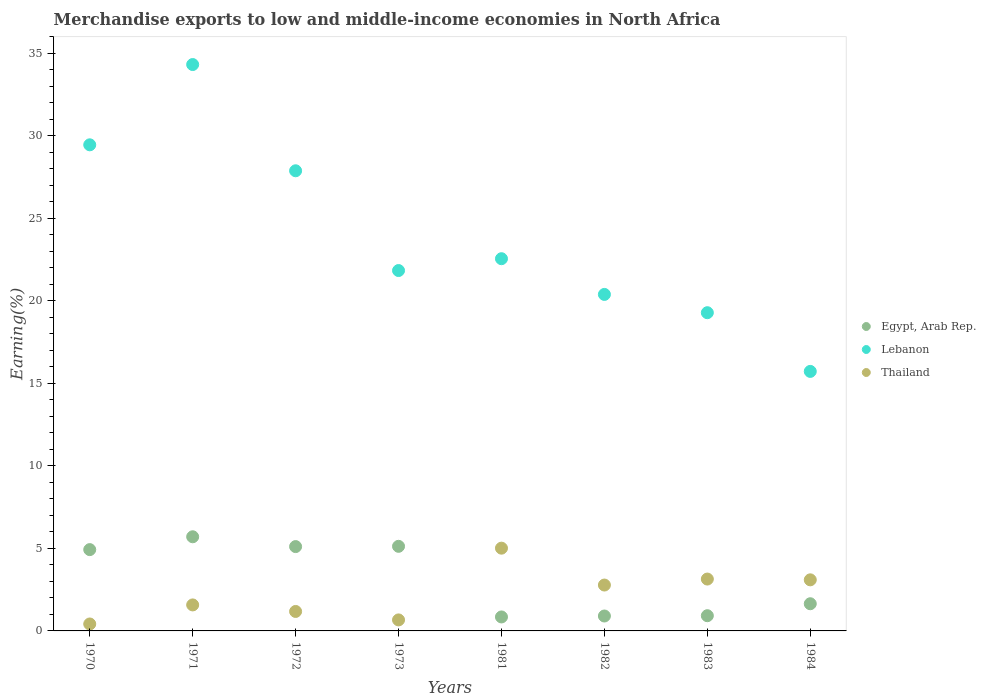Is the number of dotlines equal to the number of legend labels?
Offer a terse response. Yes. What is the percentage of amount earned from merchandise exports in Thailand in 1982?
Your response must be concise. 2.78. Across all years, what is the maximum percentage of amount earned from merchandise exports in Thailand?
Provide a succinct answer. 5.02. Across all years, what is the minimum percentage of amount earned from merchandise exports in Egypt, Arab Rep.?
Provide a succinct answer. 0.85. What is the total percentage of amount earned from merchandise exports in Egypt, Arab Rep. in the graph?
Your answer should be compact. 25.19. What is the difference between the percentage of amount earned from merchandise exports in Lebanon in 1972 and that in 1984?
Your response must be concise. 12.16. What is the difference between the percentage of amount earned from merchandise exports in Egypt, Arab Rep. in 1981 and the percentage of amount earned from merchandise exports in Lebanon in 1970?
Ensure brevity in your answer.  -28.62. What is the average percentage of amount earned from merchandise exports in Lebanon per year?
Ensure brevity in your answer.  23.94. In the year 1984, what is the difference between the percentage of amount earned from merchandise exports in Lebanon and percentage of amount earned from merchandise exports in Thailand?
Your answer should be very brief. 12.63. In how many years, is the percentage of amount earned from merchandise exports in Thailand greater than 23 %?
Your answer should be very brief. 0. What is the ratio of the percentage of amount earned from merchandise exports in Egypt, Arab Rep. in 1972 to that in 1973?
Make the answer very short. 1. What is the difference between the highest and the second highest percentage of amount earned from merchandise exports in Egypt, Arab Rep.?
Offer a terse response. 0.58. What is the difference between the highest and the lowest percentage of amount earned from merchandise exports in Lebanon?
Give a very brief answer. 18.6. In how many years, is the percentage of amount earned from merchandise exports in Thailand greater than the average percentage of amount earned from merchandise exports in Thailand taken over all years?
Offer a very short reply. 4. Is it the case that in every year, the sum of the percentage of amount earned from merchandise exports in Egypt, Arab Rep. and percentage of amount earned from merchandise exports in Thailand  is greater than the percentage of amount earned from merchandise exports in Lebanon?
Make the answer very short. No. Is the percentage of amount earned from merchandise exports in Egypt, Arab Rep. strictly greater than the percentage of amount earned from merchandise exports in Lebanon over the years?
Ensure brevity in your answer.  No. Is the percentage of amount earned from merchandise exports in Egypt, Arab Rep. strictly less than the percentage of amount earned from merchandise exports in Thailand over the years?
Your response must be concise. No. Are the values on the major ticks of Y-axis written in scientific E-notation?
Offer a very short reply. No. Does the graph contain any zero values?
Your response must be concise. No. Does the graph contain grids?
Offer a terse response. No. Where does the legend appear in the graph?
Keep it short and to the point. Center right. How are the legend labels stacked?
Make the answer very short. Vertical. What is the title of the graph?
Provide a succinct answer. Merchandise exports to low and middle-income economies in North Africa. Does "High income: nonOECD" appear as one of the legend labels in the graph?
Keep it short and to the point. No. What is the label or title of the X-axis?
Ensure brevity in your answer.  Years. What is the label or title of the Y-axis?
Make the answer very short. Earning(%). What is the Earning(%) in Egypt, Arab Rep. in 1970?
Offer a terse response. 4.93. What is the Earning(%) of Lebanon in 1970?
Keep it short and to the point. 29.46. What is the Earning(%) in Thailand in 1970?
Provide a short and direct response. 0.42. What is the Earning(%) in Egypt, Arab Rep. in 1971?
Your answer should be compact. 5.71. What is the Earning(%) of Lebanon in 1971?
Your response must be concise. 34.33. What is the Earning(%) in Thailand in 1971?
Ensure brevity in your answer.  1.58. What is the Earning(%) in Egypt, Arab Rep. in 1972?
Keep it short and to the point. 5.11. What is the Earning(%) in Lebanon in 1972?
Give a very brief answer. 27.89. What is the Earning(%) in Thailand in 1972?
Your answer should be very brief. 1.18. What is the Earning(%) of Egypt, Arab Rep. in 1973?
Your response must be concise. 5.13. What is the Earning(%) in Lebanon in 1973?
Ensure brevity in your answer.  21.84. What is the Earning(%) in Thailand in 1973?
Offer a terse response. 0.67. What is the Earning(%) of Egypt, Arab Rep. in 1981?
Ensure brevity in your answer.  0.85. What is the Earning(%) of Lebanon in 1981?
Ensure brevity in your answer.  22.56. What is the Earning(%) in Thailand in 1981?
Ensure brevity in your answer.  5.02. What is the Earning(%) of Egypt, Arab Rep. in 1982?
Your answer should be compact. 0.9. What is the Earning(%) of Lebanon in 1982?
Offer a very short reply. 20.4. What is the Earning(%) of Thailand in 1982?
Make the answer very short. 2.78. What is the Earning(%) of Egypt, Arab Rep. in 1983?
Give a very brief answer. 0.92. What is the Earning(%) of Lebanon in 1983?
Keep it short and to the point. 19.29. What is the Earning(%) in Thailand in 1983?
Your answer should be very brief. 3.14. What is the Earning(%) in Egypt, Arab Rep. in 1984?
Your answer should be very brief. 1.65. What is the Earning(%) in Lebanon in 1984?
Provide a succinct answer. 15.73. What is the Earning(%) in Thailand in 1984?
Offer a very short reply. 3.1. Across all years, what is the maximum Earning(%) of Egypt, Arab Rep.?
Offer a terse response. 5.71. Across all years, what is the maximum Earning(%) of Lebanon?
Your answer should be compact. 34.33. Across all years, what is the maximum Earning(%) of Thailand?
Your answer should be very brief. 5.02. Across all years, what is the minimum Earning(%) in Egypt, Arab Rep.?
Your answer should be very brief. 0.85. Across all years, what is the minimum Earning(%) in Lebanon?
Provide a short and direct response. 15.73. Across all years, what is the minimum Earning(%) of Thailand?
Offer a terse response. 0.42. What is the total Earning(%) in Egypt, Arab Rep. in the graph?
Ensure brevity in your answer.  25.19. What is the total Earning(%) of Lebanon in the graph?
Ensure brevity in your answer.  191.49. What is the total Earning(%) of Thailand in the graph?
Your response must be concise. 17.88. What is the difference between the Earning(%) in Egypt, Arab Rep. in 1970 and that in 1971?
Your answer should be very brief. -0.78. What is the difference between the Earning(%) of Lebanon in 1970 and that in 1971?
Make the answer very short. -4.87. What is the difference between the Earning(%) in Thailand in 1970 and that in 1971?
Your answer should be very brief. -1.15. What is the difference between the Earning(%) of Egypt, Arab Rep. in 1970 and that in 1972?
Offer a very short reply. -0.18. What is the difference between the Earning(%) in Lebanon in 1970 and that in 1972?
Keep it short and to the point. 1.57. What is the difference between the Earning(%) of Thailand in 1970 and that in 1972?
Keep it short and to the point. -0.76. What is the difference between the Earning(%) of Egypt, Arab Rep. in 1970 and that in 1973?
Offer a very short reply. -0.2. What is the difference between the Earning(%) of Lebanon in 1970 and that in 1973?
Offer a terse response. 7.62. What is the difference between the Earning(%) of Thailand in 1970 and that in 1973?
Your answer should be compact. -0.25. What is the difference between the Earning(%) in Egypt, Arab Rep. in 1970 and that in 1981?
Your response must be concise. 4.08. What is the difference between the Earning(%) of Lebanon in 1970 and that in 1981?
Your response must be concise. 6.9. What is the difference between the Earning(%) of Thailand in 1970 and that in 1981?
Offer a very short reply. -4.59. What is the difference between the Earning(%) of Egypt, Arab Rep. in 1970 and that in 1982?
Your answer should be very brief. 4.02. What is the difference between the Earning(%) in Lebanon in 1970 and that in 1982?
Provide a succinct answer. 9.07. What is the difference between the Earning(%) in Thailand in 1970 and that in 1982?
Give a very brief answer. -2.36. What is the difference between the Earning(%) of Egypt, Arab Rep. in 1970 and that in 1983?
Your response must be concise. 4.01. What is the difference between the Earning(%) of Lebanon in 1970 and that in 1983?
Your answer should be compact. 10.18. What is the difference between the Earning(%) in Thailand in 1970 and that in 1983?
Ensure brevity in your answer.  -2.72. What is the difference between the Earning(%) in Egypt, Arab Rep. in 1970 and that in 1984?
Keep it short and to the point. 3.28. What is the difference between the Earning(%) in Lebanon in 1970 and that in 1984?
Provide a short and direct response. 13.73. What is the difference between the Earning(%) in Thailand in 1970 and that in 1984?
Ensure brevity in your answer.  -2.67. What is the difference between the Earning(%) in Egypt, Arab Rep. in 1971 and that in 1972?
Your answer should be very brief. 0.59. What is the difference between the Earning(%) of Lebanon in 1971 and that in 1972?
Your answer should be very brief. 6.44. What is the difference between the Earning(%) in Thailand in 1971 and that in 1972?
Offer a terse response. 0.4. What is the difference between the Earning(%) of Egypt, Arab Rep. in 1971 and that in 1973?
Give a very brief answer. 0.58. What is the difference between the Earning(%) of Lebanon in 1971 and that in 1973?
Provide a short and direct response. 12.49. What is the difference between the Earning(%) in Thailand in 1971 and that in 1973?
Your answer should be very brief. 0.91. What is the difference between the Earning(%) in Egypt, Arab Rep. in 1971 and that in 1981?
Provide a succinct answer. 4.86. What is the difference between the Earning(%) in Lebanon in 1971 and that in 1981?
Make the answer very short. 11.77. What is the difference between the Earning(%) of Thailand in 1971 and that in 1981?
Offer a very short reply. -3.44. What is the difference between the Earning(%) in Egypt, Arab Rep. in 1971 and that in 1982?
Give a very brief answer. 4.8. What is the difference between the Earning(%) in Lebanon in 1971 and that in 1982?
Offer a very short reply. 13.93. What is the difference between the Earning(%) of Thailand in 1971 and that in 1982?
Give a very brief answer. -1.2. What is the difference between the Earning(%) in Egypt, Arab Rep. in 1971 and that in 1983?
Offer a very short reply. 4.78. What is the difference between the Earning(%) in Lebanon in 1971 and that in 1983?
Your answer should be compact. 15.04. What is the difference between the Earning(%) of Thailand in 1971 and that in 1983?
Ensure brevity in your answer.  -1.57. What is the difference between the Earning(%) in Egypt, Arab Rep. in 1971 and that in 1984?
Provide a succinct answer. 4.06. What is the difference between the Earning(%) of Lebanon in 1971 and that in 1984?
Your answer should be very brief. 18.6. What is the difference between the Earning(%) of Thailand in 1971 and that in 1984?
Provide a short and direct response. -1.52. What is the difference between the Earning(%) in Egypt, Arab Rep. in 1972 and that in 1973?
Your answer should be very brief. -0.02. What is the difference between the Earning(%) of Lebanon in 1972 and that in 1973?
Keep it short and to the point. 6.05. What is the difference between the Earning(%) in Thailand in 1972 and that in 1973?
Your answer should be compact. 0.51. What is the difference between the Earning(%) of Egypt, Arab Rep. in 1972 and that in 1981?
Offer a very short reply. 4.26. What is the difference between the Earning(%) of Lebanon in 1972 and that in 1981?
Your answer should be very brief. 5.33. What is the difference between the Earning(%) of Thailand in 1972 and that in 1981?
Offer a very short reply. -3.84. What is the difference between the Earning(%) of Egypt, Arab Rep. in 1972 and that in 1982?
Offer a terse response. 4.21. What is the difference between the Earning(%) in Lebanon in 1972 and that in 1982?
Your response must be concise. 7.49. What is the difference between the Earning(%) in Thailand in 1972 and that in 1982?
Provide a short and direct response. -1.6. What is the difference between the Earning(%) of Egypt, Arab Rep. in 1972 and that in 1983?
Offer a very short reply. 4.19. What is the difference between the Earning(%) of Lebanon in 1972 and that in 1983?
Ensure brevity in your answer.  8.6. What is the difference between the Earning(%) of Thailand in 1972 and that in 1983?
Give a very brief answer. -1.96. What is the difference between the Earning(%) of Egypt, Arab Rep. in 1972 and that in 1984?
Keep it short and to the point. 3.46. What is the difference between the Earning(%) in Lebanon in 1972 and that in 1984?
Your answer should be very brief. 12.16. What is the difference between the Earning(%) in Thailand in 1972 and that in 1984?
Your answer should be compact. -1.92. What is the difference between the Earning(%) in Egypt, Arab Rep. in 1973 and that in 1981?
Ensure brevity in your answer.  4.28. What is the difference between the Earning(%) in Lebanon in 1973 and that in 1981?
Ensure brevity in your answer.  -0.72. What is the difference between the Earning(%) of Thailand in 1973 and that in 1981?
Give a very brief answer. -4.35. What is the difference between the Earning(%) of Egypt, Arab Rep. in 1973 and that in 1982?
Offer a very short reply. 4.22. What is the difference between the Earning(%) in Lebanon in 1973 and that in 1982?
Give a very brief answer. 1.45. What is the difference between the Earning(%) in Thailand in 1973 and that in 1982?
Make the answer very short. -2.11. What is the difference between the Earning(%) in Egypt, Arab Rep. in 1973 and that in 1983?
Ensure brevity in your answer.  4.21. What is the difference between the Earning(%) in Lebanon in 1973 and that in 1983?
Offer a terse response. 2.56. What is the difference between the Earning(%) in Thailand in 1973 and that in 1983?
Your answer should be very brief. -2.48. What is the difference between the Earning(%) of Egypt, Arab Rep. in 1973 and that in 1984?
Provide a short and direct response. 3.48. What is the difference between the Earning(%) of Lebanon in 1973 and that in 1984?
Your response must be concise. 6.11. What is the difference between the Earning(%) in Thailand in 1973 and that in 1984?
Offer a very short reply. -2.43. What is the difference between the Earning(%) of Egypt, Arab Rep. in 1981 and that in 1982?
Give a very brief answer. -0.06. What is the difference between the Earning(%) in Lebanon in 1981 and that in 1982?
Your response must be concise. 2.16. What is the difference between the Earning(%) of Thailand in 1981 and that in 1982?
Offer a very short reply. 2.24. What is the difference between the Earning(%) of Egypt, Arab Rep. in 1981 and that in 1983?
Your response must be concise. -0.08. What is the difference between the Earning(%) in Lebanon in 1981 and that in 1983?
Offer a terse response. 3.27. What is the difference between the Earning(%) of Thailand in 1981 and that in 1983?
Your answer should be compact. 1.87. What is the difference between the Earning(%) in Egypt, Arab Rep. in 1981 and that in 1984?
Provide a short and direct response. -0.8. What is the difference between the Earning(%) of Lebanon in 1981 and that in 1984?
Ensure brevity in your answer.  6.83. What is the difference between the Earning(%) in Thailand in 1981 and that in 1984?
Offer a terse response. 1.92. What is the difference between the Earning(%) of Egypt, Arab Rep. in 1982 and that in 1983?
Offer a very short reply. -0.02. What is the difference between the Earning(%) of Lebanon in 1982 and that in 1983?
Offer a terse response. 1.11. What is the difference between the Earning(%) of Thailand in 1982 and that in 1983?
Make the answer very short. -0.36. What is the difference between the Earning(%) in Egypt, Arab Rep. in 1982 and that in 1984?
Your response must be concise. -0.74. What is the difference between the Earning(%) of Lebanon in 1982 and that in 1984?
Offer a terse response. 4.67. What is the difference between the Earning(%) in Thailand in 1982 and that in 1984?
Provide a short and direct response. -0.32. What is the difference between the Earning(%) in Egypt, Arab Rep. in 1983 and that in 1984?
Your response must be concise. -0.72. What is the difference between the Earning(%) of Lebanon in 1983 and that in 1984?
Provide a short and direct response. 3.56. What is the difference between the Earning(%) of Thailand in 1983 and that in 1984?
Provide a succinct answer. 0.05. What is the difference between the Earning(%) of Egypt, Arab Rep. in 1970 and the Earning(%) of Lebanon in 1971?
Make the answer very short. -29.4. What is the difference between the Earning(%) in Egypt, Arab Rep. in 1970 and the Earning(%) in Thailand in 1971?
Your answer should be very brief. 3.35. What is the difference between the Earning(%) of Lebanon in 1970 and the Earning(%) of Thailand in 1971?
Your answer should be very brief. 27.89. What is the difference between the Earning(%) in Egypt, Arab Rep. in 1970 and the Earning(%) in Lebanon in 1972?
Your response must be concise. -22.96. What is the difference between the Earning(%) of Egypt, Arab Rep. in 1970 and the Earning(%) of Thailand in 1972?
Offer a very short reply. 3.75. What is the difference between the Earning(%) in Lebanon in 1970 and the Earning(%) in Thailand in 1972?
Provide a succinct answer. 28.28. What is the difference between the Earning(%) of Egypt, Arab Rep. in 1970 and the Earning(%) of Lebanon in 1973?
Your response must be concise. -16.91. What is the difference between the Earning(%) of Egypt, Arab Rep. in 1970 and the Earning(%) of Thailand in 1973?
Give a very brief answer. 4.26. What is the difference between the Earning(%) in Lebanon in 1970 and the Earning(%) in Thailand in 1973?
Your answer should be compact. 28.8. What is the difference between the Earning(%) in Egypt, Arab Rep. in 1970 and the Earning(%) in Lebanon in 1981?
Your answer should be compact. -17.63. What is the difference between the Earning(%) in Egypt, Arab Rep. in 1970 and the Earning(%) in Thailand in 1981?
Provide a short and direct response. -0.09. What is the difference between the Earning(%) of Lebanon in 1970 and the Earning(%) of Thailand in 1981?
Provide a short and direct response. 24.45. What is the difference between the Earning(%) in Egypt, Arab Rep. in 1970 and the Earning(%) in Lebanon in 1982?
Provide a short and direct response. -15.47. What is the difference between the Earning(%) of Egypt, Arab Rep. in 1970 and the Earning(%) of Thailand in 1982?
Keep it short and to the point. 2.15. What is the difference between the Earning(%) of Lebanon in 1970 and the Earning(%) of Thailand in 1982?
Give a very brief answer. 26.68. What is the difference between the Earning(%) of Egypt, Arab Rep. in 1970 and the Earning(%) of Lebanon in 1983?
Your answer should be very brief. -14.36. What is the difference between the Earning(%) in Egypt, Arab Rep. in 1970 and the Earning(%) in Thailand in 1983?
Your response must be concise. 1.78. What is the difference between the Earning(%) in Lebanon in 1970 and the Earning(%) in Thailand in 1983?
Provide a short and direct response. 26.32. What is the difference between the Earning(%) in Egypt, Arab Rep. in 1970 and the Earning(%) in Lebanon in 1984?
Provide a short and direct response. -10.8. What is the difference between the Earning(%) of Egypt, Arab Rep. in 1970 and the Earning(%) of Thailand in 1984?
Your response must be concise. 1.83. What is the difference between the Earning(%) of Lebanon in 1970 and the Earning(%) of Thailand in 1984?
Offer a terse response. 26.37. What is the difference between the Earning(%) in Egypt, Arab Rep. in 1971 and the Earning(%) in Lebanon in 1972?
Provide a succinct answer. -22.18. What is the difference between the Earning(%) of Egypt, Arab Rep. in 1971 and the Earning(%) of Thailand in 1972?
Give a very brief answer. 4.53. What is the difference between the Earning(%) in Lebanon in 1971 and the Earning(%) in Thailand in 1972?
Offer a terse response. 33.15. What is the difference between the Earning(%) of Egypt, Arab Rep. in 1971 and the Earning(%) of Lebanon in 1973?
Give a very brief answer. -16.14. What is the difference between the Earning(%) of Egypt, Arab Rep. in 1971 and the Earning(%) of Thailand in 1973?
Ensure brevity in your answer.  5.04. What is the difference between the Earning(%) in Lebanon in 1971 and the Earning(%) in Thailand in 1973?
Your response must be concise. 33.66. What is the difference between the Earning(%) in Egypt, Arab Rep. in 1971 and the Earning(%) in Lebanon in 1981?
Your response must be concise. -16.85. What is the difference between the Earning(%) of Egypt, Arab Rep. in 1971 and the Earning(%) of Thailand in 1981?
Ensure brevity in your answer.  0.69. What is the difference between the Earning(%) of Lebanon in 1971 and the Earning(%) of Thailand in 1981?
Ensure brevity in your answer.  29.31. What is the difference between the Earning(%) in Egypt, Arab Rep. in 1971 and the Earning(%) in Lebanon in 1982?
Ensure brevity in your answer.  -14.69. What is the difference between the Earning(%) of Egypt, Arab Rep. in 1971 and the Earning(%) of Thailand in 1982?
Make the answer very short. 2.93. What is the difference between the Earning(%) of Lebanon in 1971 and the Earning(%) of Thailand in 1982?
Ensure brevity in your answer.  31.55. What is the difference between the Earning(%) of Egypt, Arab Rep. in 1971 and the Earning(%) of Lebanon in 1983?
Ensure brevity in your answer.  -13.58. What is the difference between the Earning(%) of Egypt, Arab Rep. in 1971 and the Earning(%) of Thailand in 1983?
Your answer should be very brief. 2.56. What is the difference between the Earning(%) of Lebanon in 1971 and the Earning(%) of Thailand in 1983?
Give a very brief answer. 31.18. What is the difference between the Earning(%) of Egypt, Arab Rep. in 1971 and the Earning(%) of Lebanon in 1984?
Provide a short and direct response. -10.02. What is the difference between the Earning(%) in Egypt, Arab Rep. in 1971 and the Earning(%) in Thailand in 1984?
Your answer should be compact. 2.61. What is the difference between the Earning(%) of Lebanon in 1971 and the Earning(%) of Thailand in 1984?
Your response must be concise. 31.23. What is the difference between the Earning(%) of Egypt, Arab Rep. in 1972 and the Earning(%) of Lebanon in 1973?
Give a very brief answer. -16.73. What is the difference between the Earning(%) in Egypt, Arab Rep. in 1972 and the Earning(%) in Thailand in 1973?
Ensure brevity in your answer.  4.44. What is the difference between the Earning(%) of Lebanon in 1972 and the Earning(%) of Thailand in 1973?
Provide a succinct answer. 27.22. What is the difference between the Earning(%) in Egypt, Arab Rep. in 1972 and the Earning(%) in Lebanon in 1981?
Your answer should be compact. -17.45. What is the difference between the Earning(%) in Egypt, Arab Rep. in 1972 and the Earning(%) in Thailand in 1981?
Offer a terse response. 0.1. What is the difference between the Earning(%) of Lebanon in 1972 and the Earning(%) of Thailand in 1981?
Your answer should be very brief. 22.87. What is the difference between the Earning(%) in Egypt, Arab Rep. in 1972 and the Earning(%) in Lebanon in 1982?
Offer a very short reply. -15.28. What is the difference between the Earning(%) of Egypt, Arab Rep. in 1972 and the Earning(%) of Thailand in 1982?
Provide a succinct answer. 2.33. What is the difference between the Earning(%) in Lebanon in 1972 and the Earning(%) in Thailand in 1982?
Your answer should be very brief. 25.11. What is the difference between the Earning(%) of Egypt, Arab Rep. in 1972 and the Earning(%) of Lebanon in 1983?
Provide a short and direct response. -14.18. What is the difference between the Earning(%) of Egypt, Arab Rep. in 1972 and the Earning(%) of Thailand in 1983?
Give a very brief answer. 1.97. What is the difference between the Earning(%) in Lebanon in 1972 and the Earning(%) in Thailand in 1983?
Your answer should be compact. 24.75. What is the difference between the Earning(%) in Egypt, Arab Rep. in 1972 and the Earning(%) in Lebanon in 1984?
Your answer should be very brief. -10.62. What is the difference between the Earning(%) in Egypt, Arab Rep. in 1972 and the Earning(%) in Thailand in 1984?
Keep it short and to the point. 2.02. What is the difference between the Earning(%) in Lebanon in 1972 and the Earning(%) in Thailand in 1984?
Your answer should be compact. 24.79. What is the difference between the Earning(%) of Egypt, Arab Rep. in 1973 and the Earning(%) of Lebanon in 1981?
Provide a succinct answer. -17.43. What is the difference between the Earning(%) in Egypt, Arab Rep. in 1973 and the Earning(%) in Thailand in 1981?
Keep it short and to the point. 0.11. What is the difference between the Earning(%) of Lebanon in 1973 and the Earning(%) of Thailand in 1981?
Offer a terse response. 16.83. What is the difference between the Earning(%) of Egypt, Arab Rep. in 1973 and the Earning(%) of Lebanon in 1982?
Ensure brevity in your answer.  -15.27. What is the difference between the Earning(%) of Egypt, Arab Rep. in 1973 and the Earning(%) of Thailand in 1982?
Your response must be concise. 2.35. What is the difference between the Earning(%) of Lebanon in 1973 and the Earning(%) of Thailand in 1982?
Your answer should be very brief. 19.06. What is the difference between the Earning(%) in Egypt, Arab Rep. in 1973 and the Earning(%) in Lebanon in 1983?
Ensure brevity in your answer.  -14.16. What is the difference between the Earning(%) of Egypt, Arab Rep. in 1973 and the Earning(%) of Thailand in 1983?
Make the answer very short. 1.98. What is the difference between the Earning(%) of Lebanon in 1973 and the Earning(%) of Thailand in 1983?
Your answer should be compact. 18.7. What is the difference between the Earning(%) of Egypt, Arab Rep. in 1973 and the Earning(%) of Lebanon in 1984?
Give a very brief answer. -10.6. What is the difference between the Earning(%) in Egypt, Arab Rep. in 1973 and the Earning(%) in Thailand in 1984?
Provide a succinct answer. 2.03. What is the difference between the Earning(%) in Lebanon in 1973 and the Earning(%) in Thailand in 1984?
Provide a succinct answer. 18.75. What is the difference between the Earning(%) in Egypt, Arab Rep. in 1981 and the Earning(%) in Lebanon in 1982?
Provide a short and direct response. -19.55. What is the difference between the Earning(%) in Egypt, Arab Rep. in 1981 and the Earning(%) in Thailand in 1982?
Make the answer very short. -1.93. What is the difference between the Earning(%) of Lebanon in 1981 and the Earning(%) of Thailand in 1982?
Provide a short and direct response. 19.78. What is the difference between the Earning(%) of Egypt, Arab Rep. in 1981 and the Earning(%) of Lebanon in 1983?
Keep it short and to the point. -18.44. What is the difference between the Earning(%) of Egypt, Arab Rep. in 1981 and the Earning(%) of Thailand in 1983?
Provide a succinct answer. -2.3. What is the difference between the Earning(%) in Lebanon in 1981 and the Earning(%) in Thailand in 1983?
Offer a terse response. 19.42. What is the difference between the Earning(%) in Egypt, Arab Rep. in 1981 and the Earning(%) in Lebanon in 1984?
Your answer should be very brief. -14.88. What is the difference between the Earning(%) of Egypt, Arab Rep. in 1981 and the Earning(%) of Thailand in 1984?
Ensure brevity in your answer.  -2.25. What is the difference between the Earning(%) of Lebanon in 1981 and the Earning(%) of Thailand in 1984?
Offer a very short reply. 19.46. What is the difference between the Earning(%) of Egypt, Arab Rep. in 1982 and the Earning(%) of Lebanon in 1983?
Make the answer very short. -18.38. What is the difference between the Earning(%) of Egypt, Arab Rep. in 1982 and the Earning(%) of Thailand in 1983?
Your answer should be compact. -2.24. What is the difference between the Earning(%) in Lebanon in 1982 and the Earning(%) in Thailand in 1983?
Provide a succinct answer. 17.25. What is the difference between the Earning(%) in Egypt, Arab Rep. in 1982 and the Earning(%) in Lebanon in 1984?
Offer a very short reply. -14.82. What is the difference between the Earning(%) in Egypt, Arab Rep. in 1982 and the Earning(%) in Thailand in 1984?
Ensure brevity in your answer.  -2.19. What is the difference between the Earning(%) of Lebanon in 1982 and the Earning(%) of Thailand in 1984?
Your response must be concise. 17.3. What is the difference between the Earning(%) of Egypt, Arab Rep. in 1983 and the Earning(%) of Lebanon in 1984?
Offer a terse response. -14.81. What is the difference between the Earning(%) in Egypt, Arab Rep. in 1983 and the Earning(%) in Thailand in 1984?
Provide a succinct answer. -2.17. What is the difference between the Earning(%) of Lebanon in 1983 and the Earning(%) of Thailand in 1984?
Your answer should be compact. 16.19. What is the average Earning(%) in Egypt, Arab Rep. per year?
Give a very brief answer. 3.15. What is the average Earning(%) in Lebanon per year?
Make the answer very short. 23.94. What is the average Earning(%) of Thailand per year?
Ensure brevity in your answer.  2.23. In the year 1970, what is the difference between the Earning(%) in Egypt, Arab Rep. and Earning(%) in Lebanon?
Provide a succinct answer. -24.53. In the year 1970, what is the difference between the Earning(%) in Egypt, Arab Rep. and Earning(%) in Thailand?
Your response must be concise. 4.51. In the year 1970, what is the difference between the Earning(%) in Lebanon and Earning(%) in Thailand?
Offer a terse response. 29.04. In the year 1971, what is the difference between the Earning(%) of Egypt, Arab Rep. and Earning(%) of Lebanon?
Your answer should be very brief. -28.62. In the year 1971, what is the difference between the Earning(%) in Egypt, Arab Rep. and Earning(%) in Thailand?
Offer a terse response. 4.13. In the year 1971, what is the difference between the Earning(%) of Lebanon and Earning(%) of Thailand?
Offer a terse response. 32.75. In the year 1972, what is the difference between the Earning(%) in Egypt, Arab Rep. and Earning(%) in Lebanon?
Make the answer very short. -22.78. In the year 1972, what is the difference between the Earning(%) of Egypt, Arab Rep. and Earning(%) of Thailand?
Give a very brief answer. 3.93. In the year 1972, what is the difference between the Earning(%) of Lebanon and Earning(%) of Thailand?
Your answer should be very brief. 26.71. In the year 1973, what is the difference between the Earning(%) in Egypt, Arab Rep. and Earning(%) in Lebanon?
Ensure brevity in your answer.  -16.71. In the year 1973, what is the difference between the Earning(%) of Egypt, Arab Rep. and Earning(%) of Thailand?
Make the answer very short. 4.46. In the year 1973, what is the difference between the Earning(%) of Lebanon and Earning(%) of Thailand?
Ensure brevity in your answer.  21.18. In the year 1981, what is the difference between the Earning(%) in Egypt, Arab Rep. and Earning(%) in Lebanon?
Offer a very short reply. -21.71. In the year 1981, what is the difference between the Earning(%) in Egypt, Arab Rep. and Earning(%) in Thailand?
Offer a terse response. -4.17. In the year 1981, what is the difference between the Earning(%) in Lebanon and Earning(%) in Thailand?
Your answer should be very brief. 17.54. In the year 1982, what is the difference between the Earning(%) of Egypt, Arab Rep. and Earning(%) of Lebanon?
Your response must be concise. -19.49. In the year 1982, what is the difference between the Earning(%) of Egypt, Arab Rep. and Earning(%) of Thailand?
Keep it short and to the point. -1.88. In the year 1982, what is the difference between the Earning(%) in Lebanon and Earning(%) in Thailand?
Your response must be concise. 17.61. In the year 1983, what is the difference between the Earning(%) in Egypt, Arab Rep. and Earning(%) in Lebanon?
Your response must be concise. -18.36. In the year 1983, what is the difference between the Earning(%) of Egypt, Arab Rep. and Earning(%) of Thailand?
Offer a very short reply. -2.22. In the year 1983, what is the difference between the Earning(%) in Lebanon and Earning(%) in Thailand?
Your answer should be compact. 16.14. In the year 1984, what is the difference between the Earning(%) of Egypt, Arab Rep. and Earning(%) of Lebanon?
Provide a succinct answer. -14.08. In the year 1984, what is the difference between the Earning(%) of Egypt, Arab Rep. and Earning(%) of Thailand?
Offer a very short reply. -1.45. In the year 1984, what is the difference between the Earning(%) in Lebanon and Earning(%) in Thailand?
Keep it short and to the point. 12.63. What is the ratio of the Earning(%) of Egypt, Arab Rep. in 1970 to that in 1971?
Your response must be concise. 0.86. What is the ratio of the Earning(%) of Lebanon in 1970 to that in 1971?
Your answer should be very brief. 0.86. What is the ratio of the Earning(%) of Thailand in 1970 to that in 1971?
Provide a succinct answer. 0.27. What is the ratio of the Earning(%) of Egypt, Arab Rep. in 1970 to that in 1972?
Your answer should be very brief. 0.96. What is the ratio of the Earning(%) in Lebanon in 1970 to that in 1972?
Offer a very short reply. 1.06. What is the ratio of the Earning(%) of Thailand in 1970 to that in 1972?
Your answer should be very brief. 0.36. What is the ratio of the Earning(%) of Egypt, Arab Rep. in 1970 to that in 1973?
Provide a short and direct response. 0.96. What is the ratio of the Earning(%) of Lebanon in 1970 to that in 1973?
Provide a succinct answer. 1.35. What is the ratio of the Earning(%) in Thailand in 1970 to that in 1973?
Give a very brief answer. 0.63. What is the ratio of the Earning(%) in Egypt, Arab Rep. in 1970 to that in 1981?
Provide a succinct answer. 5.82. What is the ratio of the Earning(%) of Lebanon in 1970 to that in 1981?
Provide a short and direct response. 1.31. What is the ratio of the Earning(%) in Thailand in 1970 to that in 1981?
Provide a succinct answer. 0.08. What is the ratio of the Earning(%) of Egypt, Arab Rep. in 1970 to that in 1982?
Make the answer very short. 5.45. What is the ratio of the Earning(%) in Lebanon in 1970 to that in 1982?
Offer a very short reply. 1.44. What is the ratio of the Earning(%) in Thailand in 1970 to that in 1982?
Offer a very short reply. 0.15. What is the ratio of the Earning(%) in Egypt, Arab Rep. in 1970 to that in 1983?
Make the answer very short. 5.34. What is the ratio of the Earning(%) of Lebanon in 1970 to that in 1983?
Ensure brevity in your answer.  1.53. What is the ratio of the Earning(%) in Thailand in 1970 to that in 1983?
Ensure brevity in your answer.  0.13. What is the ratio of the Earning(%) in Egypt, Arab Rep. in 1970 to that in 1984?
Your answer should be very brief. 2.99. What is the ratio of the Earning(%) in Lebanon in 1970 to that in 1984?
Give a very brief answer. 1.87. What is the ratio of the Earning(%) in Thailand in 1970 to that in 1984?
Your response must be concise. 0.14. What is the ratio of the Earning(%) of Egypt, Arab Rep. in 1971 to that in 1972?
Keep it short and to the point. 1.12. What is the ratio of the Earning(%) of Lebanon in 1971 to that in 1972?
Provide a succinct answer. 1.23. What is the ratio of the Earning(%) in Thailand in 1971 to that in 1972?
Provide a short and direct response. 1.34. What is the ratio of the Earning(%) in Egypt, Arab Rep. in 1971 to that in 1973?
Provide a short and direct response. 1.11. What is the ratio of the Earning(%) of Lebanon in 1971 to that in 1973?
Offer a very short reply. 1.57. What is the ratio of the Earning(%) in Thailand in 1971 to that in 1973?
Offer a very short reply. 2.36. What is the ratio of the Earning(%) in Egypt, Arab Rep. in 1971 to that in 1981?
Your response must be concise. 6.74. What is the ratio of the Earning(%) of Lebanon in 1971 to that in 1981?
Give a very brief answer. 1.52. What is the ratio of the Earning(%) of Thailand in 1971 to that in 1981?
Your response must be concise. 0.31. What is the ratio of the Earning(%) of Egypt, Arab Rep. in 1971 to that in 1982?
Keep it short and to the point. 6.31. What is the ratio of the Earning(%) of Lebanon in 1971 to that in 1982?
Your answer should be compact. 1.68. What is the ratio of the Earning(%) in Thailand in 1971 to that in 1982?
Your answer should be compact. 0.57. What is the ratio of the Earning(%) in Egypt, Arab Rep. in 1971 to that in 1983?
Your answer should be very brief. 6.19. What is the ratio of the Earning(%) of Lebanon in 1971 to that in 1983?
Give a very brief answer. 1.78. What is the ratio of the Earning(%) in Thailand in 1971 to that in 1983?
Your answer should be very brief. 0.5. What is the ratio of the Earning(%) of Egypt, Arab Rep. in 1971 to that in 1984?
Make the answer very short. 3.46. What is the ratio of the Earning(%) of Lebanon in 1971 to that in 1984?
Your response must be concise. 2.18. What is the ratio of the Earning(%) of Thailand in 1971 to that in 1984?
Ensure brevity in your answer.  0.51. What is the ratio of the Earning(%) in Egypt, Arab Rep. in 1972 to that in 1973?
Offer a very short reply. 1. What is the ratio of the Earning(%) in Lebanon in 1972 to that in 1973?
Provide a short and direct response. 1.28. What is the ratio of the Earning(%) of Thailand in 1972 to that in 1973?
Ensure brevity in your answer.  1.77. What is the ratio of the Earning(%) of Egypt, Arab Rep. in 1972 to that in 1981?
Offer a very short reply. 6.03. What is the ratio of the Earning(%) in Lebanon in 1972 to that in 1981?
Offer a very short reply. 1.24. What is the ratio of the Earning(%) in Thailand in 1972 to that in 1981?
Ensure brevity in your answer.  0.24. What is the ratio of the Earning(%) in Egypt, Arab Rep. in 1972 to that in 1982?
Ensure brevity in your answer.  5.65. What is the ratio of the Earning(%) of Lebanon in 1972 to that in 1982?
Your answer should be compact. 1.37. What is the ratio of the Earning(%) in Thailand in 1972 to that in 1982?
Give a very brief answer. 0.42. What is the ratio of the Earning(%) of Egypt, Arab Rep. in 1972 to that in 1983?
Your response must be concise. 5.54. What is the ratio of the Earning(%) of Lebanon in 1972 to that in 1983?
Give a very brief answer. 1.45. What is the ratio of the Earning(%) in Thailand in 1972 to that in 1983?
Provide a succinct answer. 0.38. What is the ratio of the Earning(%) in Egypt, Arab Rep. in 1972 to that in 1984?
Your response must be concise. 3.1. What is the ratio of the Earning(%) in Lebanon in 1972 to that in 1984?
Your answer should be very brief. 1.77. What is the ratio of the Earning(%) in Thailand in 1972 to that in 1984?
Provide a succinct answer. 0.38. What is the ratio of the Earning(%) of Egypt, Arab Rep. in 1973 to that in 1981?
Ensure brevity in your answer.  6.05. What is the ratio of the Earning(%) in Lebanon in 1973 to that in 1981?
Keep it short and to the point. 0.97. What is the ratio of the Earning(%) of Thailand in 1973 to that in 1981?
Make the answer very short. 0.13. What is the ratio of the Earning(%) of Egypt, Arab Rep. in 1973 to that in 1982?
Your response must be concise. 5.67. What is the ratio of the Earning(%) in Lebanon in 1973 to that in 1982?
Ensure brevity in your answer.  1.07. What is the ratio of the Earning(%) of Thailand in 1973 to that in 1982?
Offer a very short reply. 0.24. What is the ratio of the Earning(%) in Egypt, Arab Rep. in 1973 to that in 1983?
Your answer should be compact. 5.56. What is the ratio of the Earning(%) of Lebanon in 1973 to that in 1983?
Offer a terse response. 1.13. What is the ratio of the Earning(%) in Thailand in 1973 to that in 1983?
Offer a very short reply. 0.21. What is the ratio of the Earning(%) in Egypt, Arab Rep. in 1973 to that in 1984?
Make the answer very short. 3.11. What is the ratio of the Earning(%) in Lebanon in 1973 to that in 1984?
Provide a short and direct response. 1.39. What is the ratio of the Earning(%) in Thailand in 1973 to that in 1984?
Provide a succinct answer. 0.22. What is the ratio of the Earning(%) of Egypt, Arab Rep. in 1981 to that in 1982?
Give a very brief answer. 0.94. What is the ratio of the Earning(%) in Lebanon in 1981 to that in 1982?
Offer a very short reply. 1.11. What is the ratio of the Earning(%) of Thailand in 1981 to that in 1982?
Provide a short and direct response. 1.8. What is the ratio of the Earning(%) of Egypt, Arab Rep. in 1981 to that in 1983?
Your answer should be very brief. 0.92. What is the ratio of the Earning(%) of Lebanon in 1981 to that in 1983?
Keep it short and to the point. 1.17. What is the ratio of the Earning(%) in Thailand in 1981 to that in 1983?
Offer a very short reply. 1.6. What is the ratio of the Earning(%) in Egypt, Arab Rep. in 1981 to that in 1984?
Keep it short and to the point. 0.51. What is the ratio of the Earning(%) of Lebanon in 1981 to that in 1984?
Keep it short and to the point. 1.43. What is the ratio of the Earning(%) in Thailand in 1981 to that in 1984?
Your answer should be very brief. 1.62. What is the ratio of the Earning(%) of Egypt, Arab Rep. in 1982 to that in 1983?
Your response must be concise. 0.98. What is the ratio of the Earning(%) in Lebanon in 1982 to that in 1983?
Your answer should be compact. 1.06. What is the ratio of the Earning(%) in Thailand in 1982 to that in 1983?
Offer a very short reply. 0.88. What is the ratio of the Earning(%) of Egypt, Arab Rep. in 1982 to that in 1984?
Ensure brevity in your answer.  0.55. What is the ratio of the Earning(%) in Lebanon in 1982 to that in 1984?
Make the answer very short. 1.3. What is the ratio of the Earning(%) of Thailand in 1982 to that in 1984?
Your response must be concise. 0.9. What is the ratio of the Earning(%) of Egypt, Arab Rep. in 1983 to that in 1984?
Provide a succinct answer. 0.56. What is the ratio of the Earning(%) in Lebanon in 1983 to that in 1984?
Offer a terse response. 1.23. What is the ratio of the Earning(%) of Thailand in 1983 to that in 1984?
Provide a short and direct response. 1.02. What is the difference between the highest and the second highest Earning(%) in Egypt, Arab Rep.?
Your answer should be very brief. 0.58. What is the difference between the highest and the second highest Earning(%) in Lebanon?
Keep it short and to the point. 4.87. What is the difference between the highest and the second highest Earning(%) of Thailand?
Give a very brief answer. 1.87. What is the difference between the highest and the lowest Earning(%) in Egypt, Arab Rep.?
Your answer should be compact. 4.86. What is the difference between the highest and the lowest Earning(%) of Lebanon?
Keep it short and to the point. 18.6. What is the difference between the highest and the lowest Earning(%) of Thailand?
Keep it short and to the point. 4.59. 